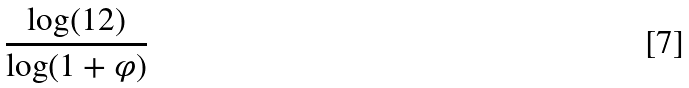<formula> <loc_0><loc_0><loc_500><loc_500>\frac { \log ( 1 2 ) } { \log ( 1 + \varphi ) }</formula> 